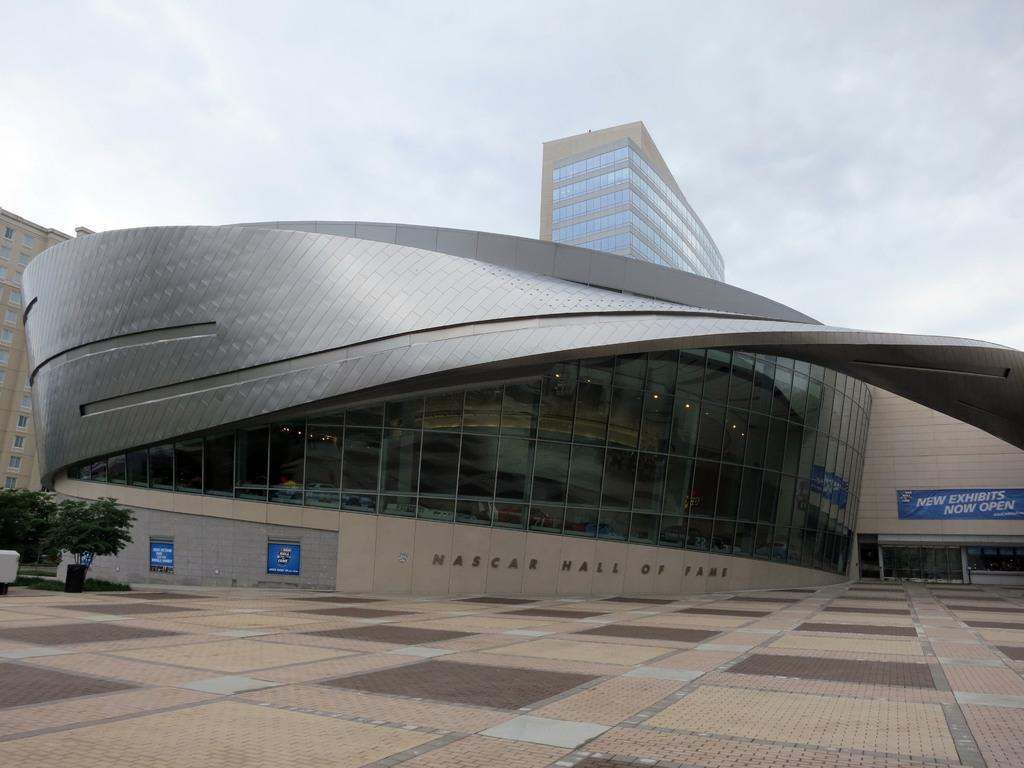Provide a one-sentence caption for the provided image. At the Nascar Hall of Fame, new exhibits are now open. 